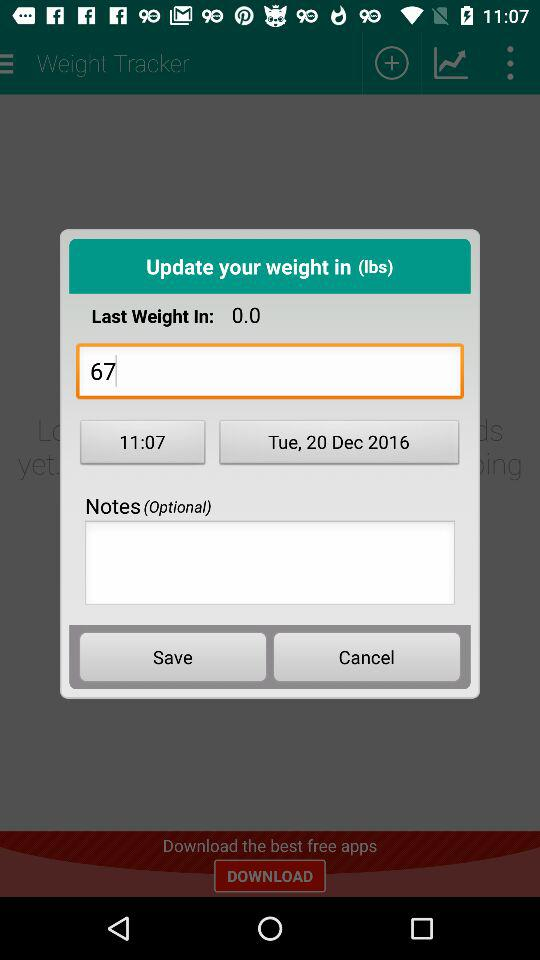Which notes are written?
When the provided information is insufficient, respond with <no answer>. <no answer> 